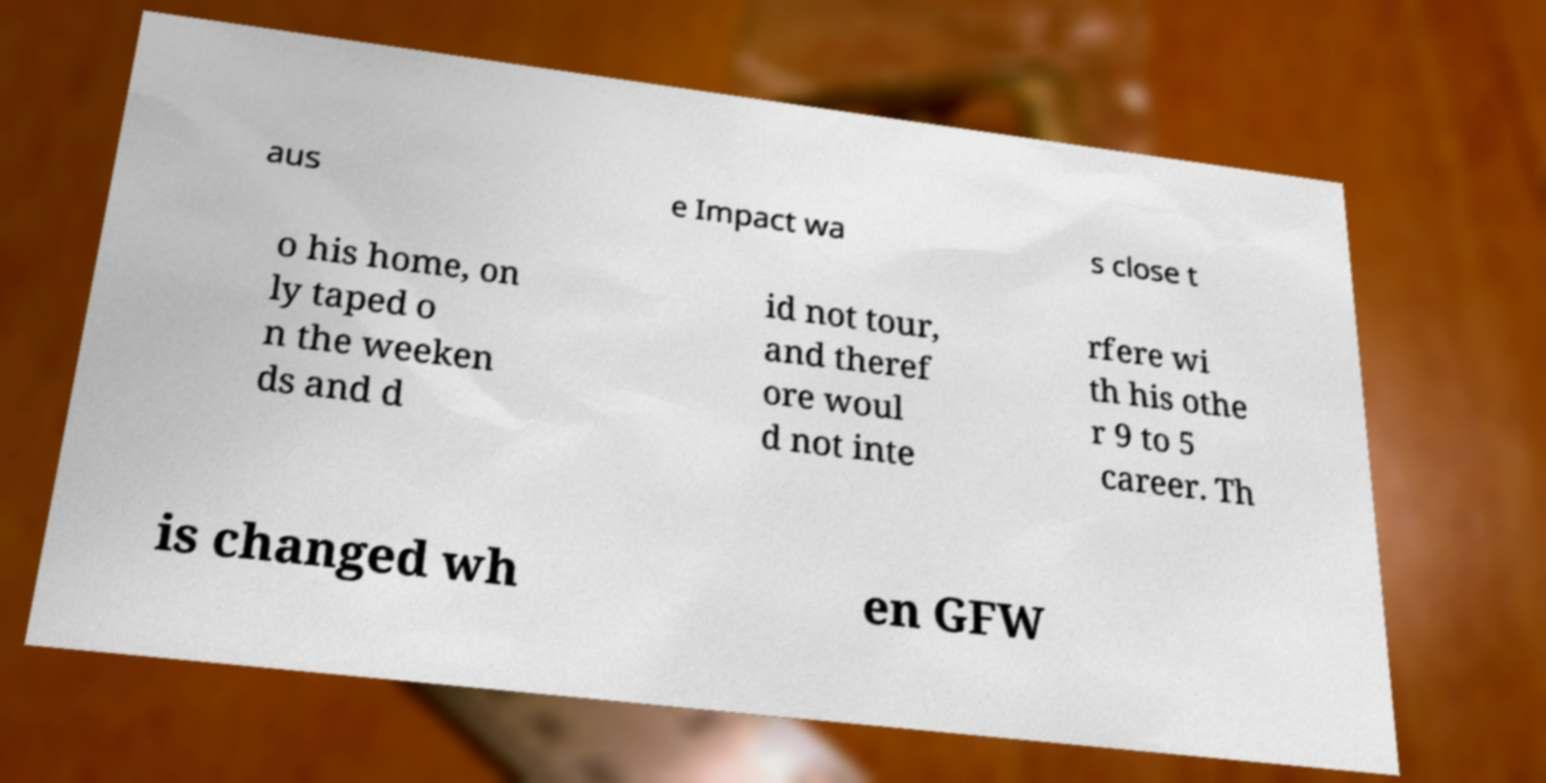Please read and relay the text visible in this image. What does it say? aus e Impact wa s close t o his home, on ly taped o n the weeken ds and d id not tour, and theref ore woul d not inte rfere wi th his othe r 9 to 5 career. Th is changed wh en GFW 